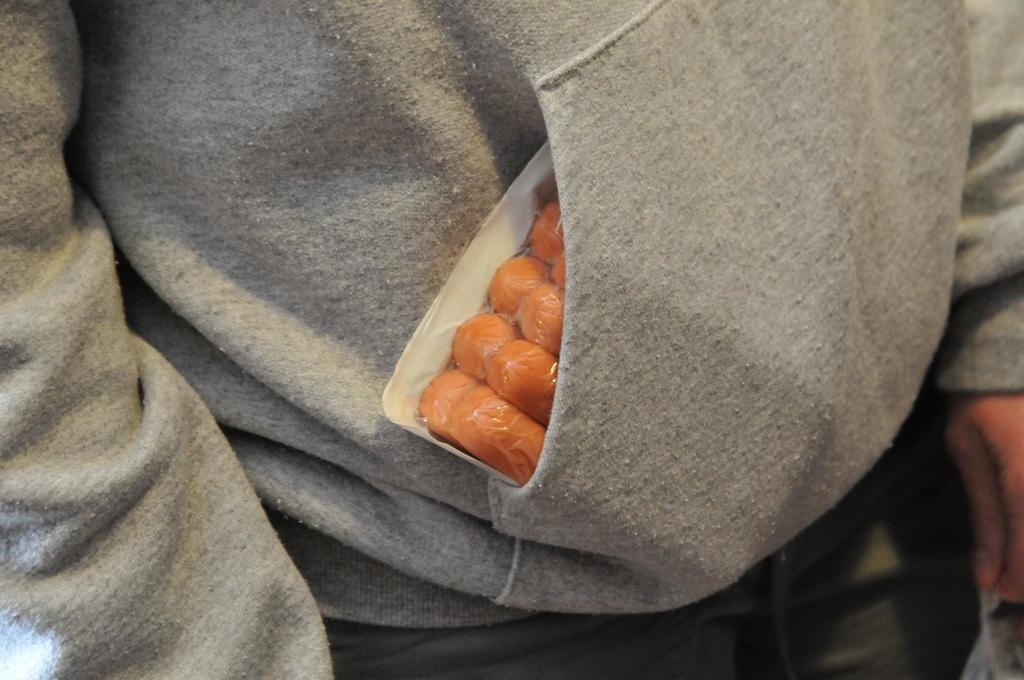Who or what is present in the image? There is a person in the image. What can be observed about the person's attire? The person is wearing clothes. What else can be seen in the image besides the person? There is a food item in the image. Is there a ghost visible in the image? No, there is no ghost present in the image. What type of screw can be seen holding the food item in place? There is no screw present in the image; it is a food item without any visible fasteners. 